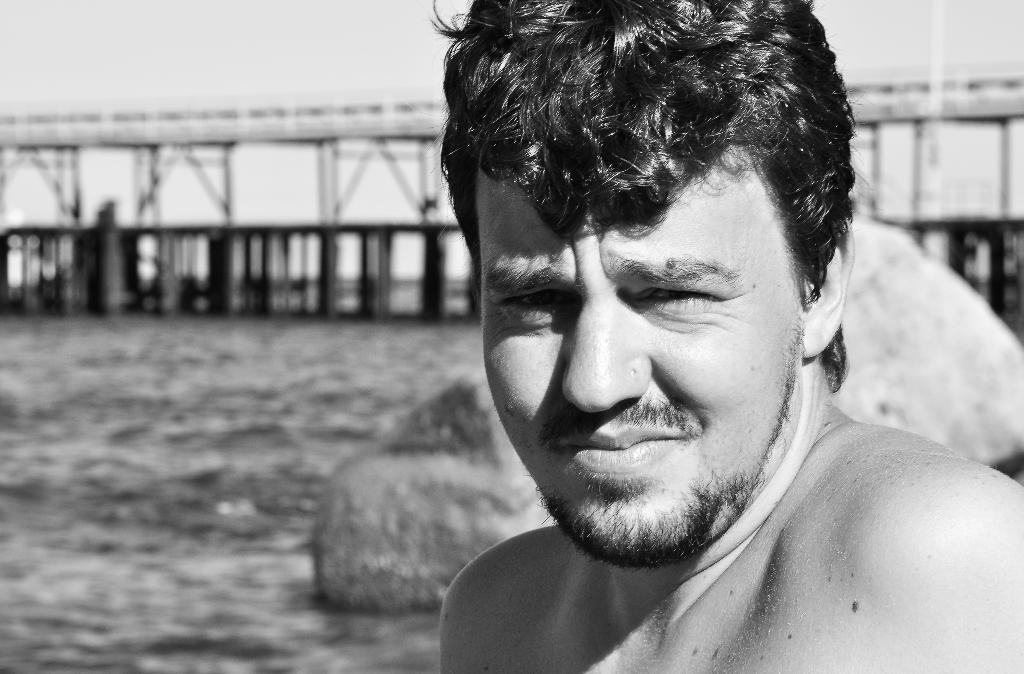In one or two sentences, can you explain what this image depicts? In this picture I can observe a man in the middle of the picture. On the left side I can observe river. The background is blurred. 